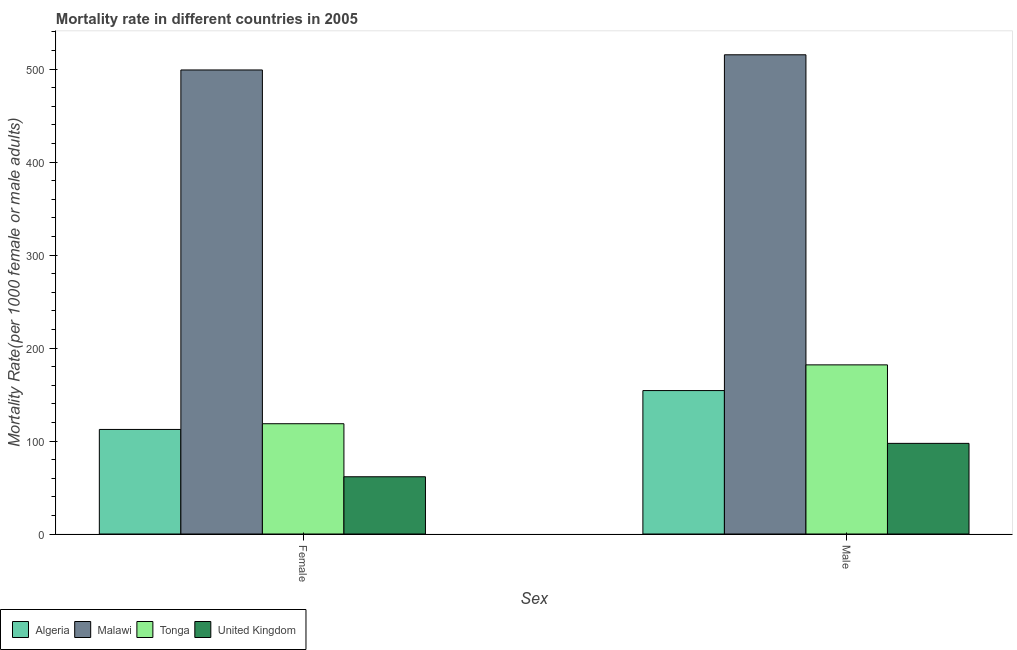How many different coloured bars are there?
Provide a succinct answer. 4. How many groups of bars are there?
Your answer should be very brief. 2. Are the number of bars per tick equal to the number of legend labels?
Your answer should be compact. Yes. How many bars are there on the 1st tick from the right?
Your answer should be very brief. 4. What is the male mortality rate in Malawi?
Make the answer very short. 515.46. Across all countries, what is the maximum female mortality rate?
Keep it short and to the point. 499.13. Across all countries, what is the minimum female mortality rate?
Your answer should be very brief. 61.57. In which country was the female mortality rate maximum?
Your answer should be compact. Malawi. In which country was the male mortality rate minimum?
Your answer should be very brief. United Kingdom. What is the total female mortality rate in the graph?
Offer a very short reply. 791.78. What is the difference between the female mortality rate in United Kingdom and that in Tonga?
Keep it short and to the point. -57.04. What is the difference between the male mortality rate in United Kingdom and the female mortality rate in Malawi?
Offer a terse response. -401.65. What is the average male mortality rate per country?
Your answer should be compact. 237.29. What is the difference between the male mortality rate and female mortality rate in Tonga?
Give a very brief answer. 63.31. What is the ratio of the female mortality rate in Algeria to that in Malawi?
Your answer should be compact. 0.23. Is the female mortality rate in Algeria less than that in Tonga?
Give a very brief answer. Yes. What does the 2nd bar from the left in Male represents?
Keep it short and to the point. Malawi. What does the 1st bar from the right in Female represents?
Make the answer very short. United Kingdom. How many bars are there?
Your answer should be compact. 8. Are all the bars in the graph horizontal?
Your answer should be very brief. No. How many countries are there in the graph?
Your answer should be compact. 4. What is the difference between two consecutive major ticks on the Y-axis?
Ensure brevity in your answer.  100. Where does the legend appear in the graph?
Provide a short and direct response. Bottom left. What is the title of the graph?
Your answer should be compact. Mortality rate in different countries in 2005. Does "Mexico" appear as one of the legend labels in the graph?
Give a very brief answer. No. What is the label or title of the X-axis?
Provide a short and direct response. Sex. What is the label or title of the Y-axis?
Provide a short and direct response. Mortality Rate(per 1000 female or male adults). What is the Mortality Rate(per 1000 female or male adults) in Algeria in Female?
Your answer should be very brief. 112.46. What is the Mortality Rate(per 1000 female or male adults) in Malawi in Female?
Provide a succinct answer. 499.13. What is the Mortality Rate(per 1000 female or male adults) in Tonga in Female?
Your answer should be very brief. 118.62. What is the Mortality Rate(per 1000 female or male adults) of United Kingdom in Female?
Provide a succinct answer. 61.57. What is the Mortality Rate(per 1000 female or male adults) of Algeria in Male?
Keep it short and to the point. 154.28. What is the Mortality Rate(per 1000 female or male adults) of Malawi in Male?
Provide a short and direct response. 515.46. What is the Mortality Rate(per 1000 female or male adults) in Tonga in Male?
Ensure brevity in your answer.  181.93. What is the Mortality Rate(per 1000 female or male adults) of United Kingdom in Male?
Provide a short and direct response. 97.48. Across all Sex, what is the maximum Mortality Rate(per 1000 female or male adults) in Algeria?
Offer a very short reply. 154.28. Across all Sex, what is the maximum Mortality Rate(per 1000 female or male adults) in Malawi?
Give a very brief answer. 515.46. Across all Sex, what is the maximum Mortality Rate(per 1000 female or male adults) of Tonga?
Provide a short and direct response. 181.93. Across all Sex, what is the maximum Mortality Rate(per 1000 female or male adults) of United Kingdom?
Your response must be concise. 97.48. Across all Sex, what is the minimum Mortality Rate(per 1000 female or male adults) in Algeria?
Provide a succinct answer. 112.46. Across all Sex, what is the minimum Mortality Rate(per 1000 female or male adults) of Malawi?
Ensure brevity in your answer.  499.13. Across all Sex, what is the minimum Mortality Rate(per 1000 female or male adults) of Tonga?
Offer a terse response. 118.62. Across all Sex, what is the minimum Mortality Rate(per 1000 female or male adults) in United Kingdom?
Provide a succinct answer. 61.57. What is the total Mortality Rate(per 1000 female or male adults) in Algeria in the graph?
Ensure brevity in your answer.  266.73. What is the total Mortality Rate(per 1000 female or male adults) in Malawi in the graph?
Offer a very short reply. 1014.59. What is the total Mortality Rate(per 1000 female or male adults) in Tonga in the graph?
Give a very brief answer. 300.55. What is the total Mortality Rate(per 1000 female or male adults) in United Kingdom in the graph?
Your answer should be very brief. 159.05. What is the difference between the Mortality Rate(per 1000 female or male adults) of Algeria in Female and that in Male?
Give a very brief answer. -41.82. What is the difference between the Mortality Rate(per 1000 female or male adults) of Malawi in Female and that in Male?
Provide a short and direct response. -16.33. What is the difference between the Mortality Rate(per 1000 female or male adults) in Tonga in Female and that in Male?
Offer a terse response. -63.31. What is the difference between the Mortality Rate(per 1000 female or male adults) in United Kingdom in Female and that in Male?
Your answer should be compact. -35.91. What is the difference between the Mortality Rate(per 1000 female or male adults) of Algeria in Female and the Mortality Rate(per 1000 female or male adults) of Malawi in Male?
Offer a terse response. -403. What is the difference between the Mortality Rate(per 1000 female or male adults) of Algeria in Female and the Mortality Rate(per 1000 female or male adults) of Tonga in Male?
Your answer should be compact. -69.47. What is the difference between the Mortality Rate(per 1000 female or male adults) of Algeria in Female and the Mortality Rate(per 1000 female or male adults) of United Kingdom in Male?
Your response must be concise. 14.97. What is the difference between the Mortality Rate(per 1000 female or male adults) in Malawi in Female and the Mortality Rate(per 1000 female or male adults) in Tonga in Male?
Your response must be concise. 317.2. What is the difference between the Mortality Rate(per 1000 female or male adults) of Malawi in Female and the Mortality Rate(per 1000 female or male adults) of United Kingdom in Male?
Offer a very short reply. 401.65. What is the difference between the Mortality Rate(per 1000 female or male adults) in Tonga in Female and the Mortality Rate(per 1000 female or male adults) in United Kingdom in Male?
Offer a terse response. 21.13. What is the average Mortality Rate(per 1000 female or male adults) of Algeria per Sex?
Your answer should be very brief. 133.37. What is the average Mortality Rate(per 1000 female or male adults) in Malawi per Sex?
Make the answer very short. 507.3. What is the average Mortality Rate(per 1000 female or male adults) in Tonga per Sex?
Your response must be concise. 150.27. What is the average Mortality Rate(per 1000 female or male adults) in United Kingdom per Sex?
Offer a terse response. 79.53. What is the difference between the Mortality Rate(per 1000 female or male adults) of Algeria and Mortality Rate(per 1000 female or male adults) of Malawi in Female?
Your response must be concise. -386.68. What is the difference between the Mortality Rate(per 1000 female or male adults) of Algeria and Mortality Rate(per 1000 female or male adults) of Tonga in Female?
Your answer should be very brief. -6.16. What is the difference between the Mortality Rate(per 1000 female or male adults) in Algeria and Mortality Rate(per 1000 female or male adults) in United Kingdom in Female?
Offer a terse response. 50.89. What is the difference between the Mortality Rate(per 1000 female or male adults) in Malawi and Mortality Rate(per 1000 female or male adults) in Tonga in Female?
Your answer should be very brief. 380.52. What is the difference between the Mortality Rate(per 1000 female or male adults) in Malawi and Mortality Rate(per 1000 female or male adults) in United Kingdom in Female?
Make the answer very short. 437.56. What is the difference between the Mortality Rate(per 1000 female or male adults) in Tonga and Mortality Rate(per 1000 female or male adults) in United Kingdom in Female?
Your response must be concise. 57.05. What is the difference between the Mortality Rate(per 1000 female or male adults) in Algeria and Mortality Rate(per 1000 female or male adults) in Malawi in Male?
Provide a succinct answer. -361.19. What is the difference between the Mortality Rate(per 1000 female or male adults) of Algeria and Mortality Rate(per 1000 female or male adults) of Tonga in Male?
Give a very brief answer. -27.66. What is the difference between the Mortality Rate(per 1000 female or male adults) of Algeria and Mortality Rate(per 1000 female or male adults) of United Kingdom in Male?
Give a very brief answer. 56.79. What is the difference between the Mortality Rate(per 1000 female or male adults) of Malawi and Mortality Rate(per 1000 female or male adults) of Tonga in Male?
Provide a succinct answer. 333.53. What is the difference between the Mortality Rate(per 1000 female or male adults) in Malawi and Mortality Rate(per 1000 female or male adults) in United Kingdom in Male?
Offer a very short reply. 417.98. What is the difference between the Mortality Rate(per 1000 female or male adults) of Tonga and Mortality Rate(per 1000 female or male adults) of United Kingdom in Male?
Provide a short and direct response. 84.45. What is the ratio of the Mortality Rate(per 1000 female or male adults) of Algeria in Female to that in Male?
Give a very brief answer. 0.73. What is the ratio of the Mortality Rate(per 1000 female or male adults) in Malawi in Female to that in Male?
Keep it short and to the point. 0.97. What is the ratio of the Mortality Rate(per 1000 female or male adults) in Tonga in Female to that in Male?
Make the answer very short. 0.65. What is the ratio of the Mortality Rate(per 1000 female or male adults) in United Kingdom in Female to that in Male?
Your answer should be very brief. 0.63. What is the difference between the highest and the second highest Mortality Rate(per 1000 female or male adults) in Algeria?
Provide a short and direct response. 41.82. What is the difference between the highest and the second highest Mortality Rate(per 1000 female or male adults) of Malawi?
Provide a short and direct response. 16.33. What is the difference between the highest and the second highest Mortality Rate(per 1000 female or male adults) of Tonga?
Your answer should be compact. 63.31. What is the difference between the highest and the second highest Mortality Rate(per 1000 female or male adults) in United Kingdom?
Your answer should be compact. 35.91. What is the difference between the highest and the lowest Mortality Rate(per 1000 female or male adults) in Algeria?
Offer a very short reply. 41.82. What is the difference between the highest and the lowest Mortality Rate(per 1000 female or male adults) in Malawi?
Your answer should be very brief. 16.33. What is the difference between the highest and the lowest Mortality Rate(per 1000 female or male adults) of Tonga?
Ensure brevity in your answer.  63.31. What is the difference between the highest and the lowest Mortality Rate(per 1000 female or male adults) in United Kingdom?
Make the answer very short. 35.91. 